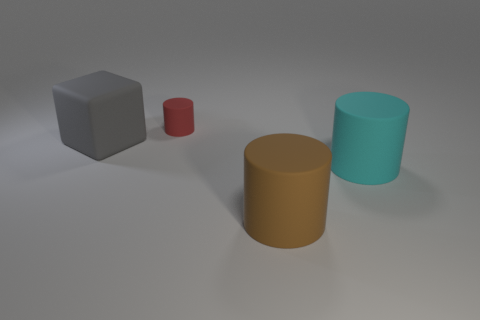What number of small rubber objects are the same color as the large cube?
Your response must be concise. 0. There is a big cylinder behind the large brown rubber cylinder; what is its material?
Your answer should be very brief. Rubber. What number of small things are gray rubber cubes or blue cylinders?
Provide a succinct answer. 0. Is there a gray block that has the same material as the red thing?
Your answer should be compact. Yes. Do the cylinder that is behind the cyan rubber thing and the gray thing have the same size?
Your response must be concise. No. Are there any matte objects on the right side of the cylinder that is behind the rubber thing that is to the left of the tiny red cylinder?
Ensure brevity in your answer.  Yes. What number of matte objects are tiny cylinders or cylinders?
Ensure brevity in your answer.  3. What number of other things are the same shape as the big cyan object?
Your response must be concise. 2. Are there more small red cylinders than large spheres?
Your answer should be compact. Yes. What is the size of the matte object on the left side of the rubber cylinder that is behind the matte object to the left of the small red rubber thing?
Offer a very short reply. Large. 